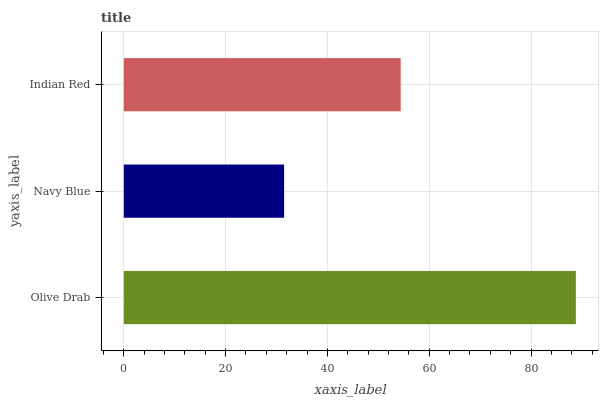Is Navy Blue the minimum?
Answer yes or no. Yes. Is Olive Drab the maximum?
Answer yes or no. Yes. Is Indian Red the minimum?
Answer yes or no. No. Is Indian Red the maximum?
Answer yes or no. No. Is Indian Red greater than Navy Blue?
Answer yes or no. Yes. Is Navy Blue less than Indian Red?
Answer yes or no. Yes. Is Navy Blue greater than Indian Red?
Answer yes or no. No. Is Indian Red less than Navy Blue?
Answer yes or no. No. Is Indian Red the high median?
Answer yes or no. Yes. Is Indian Red the low median?
Answer yes or no. Yes. Is Navy Blue the high median?
Answer yes or no. No. Is Olive Drab the low median?
Answer yes or no. No. 